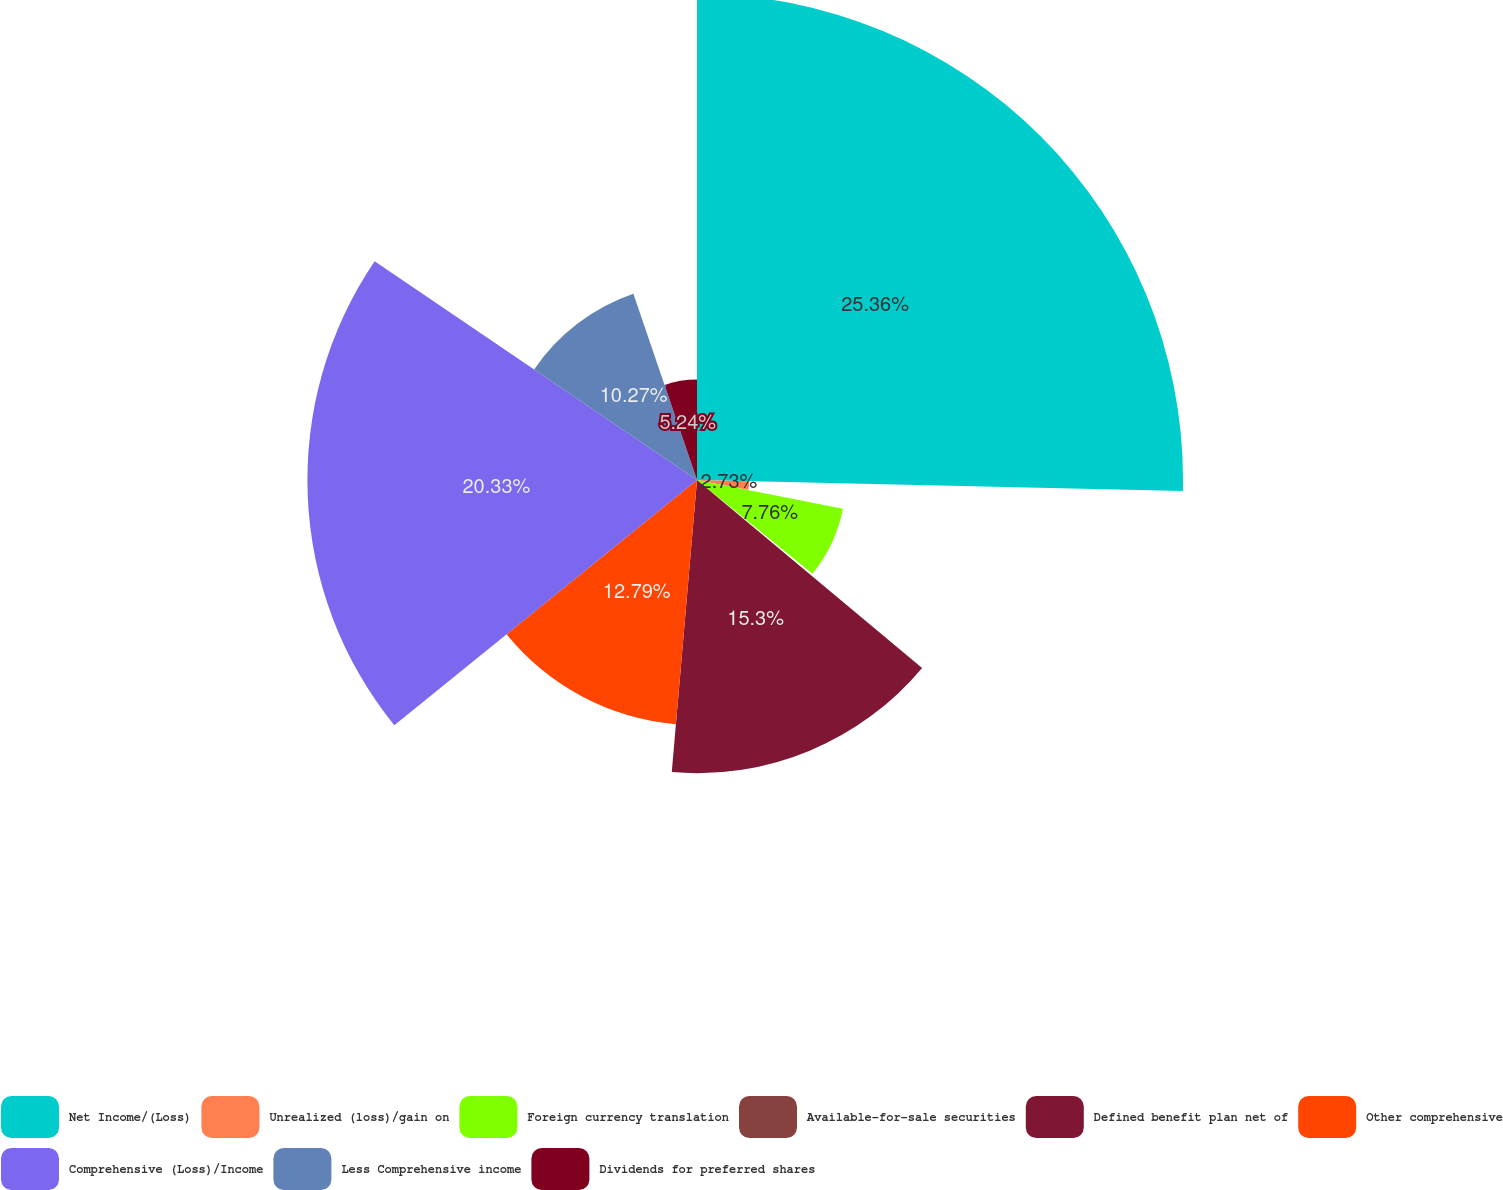Convert chart to OTSL. <chart><loc_0><loc_0><loc_500><loc_500><pie_chart><fcel>Net Income/(Loss)<fcel>Unrealized (loss)/gain on<fcel>Foreign currency translation<fcel>Available-for-sale securities<fcel>Defined benefit plan net of<fcel>Other comprehensive<fcel>Comprehensive (Loss)/Income<fcel>Less Comprehensive income<fcel>Dividends for preferred shares<nl><fcel>25.36%<fcel>2.73%<fcel>7.76%<fcel>0.22%<fcel>15.3%<fcel>12.79%<fcel>20.33%<fcel>10.27%<fcel>5.24%<nl></chart> 